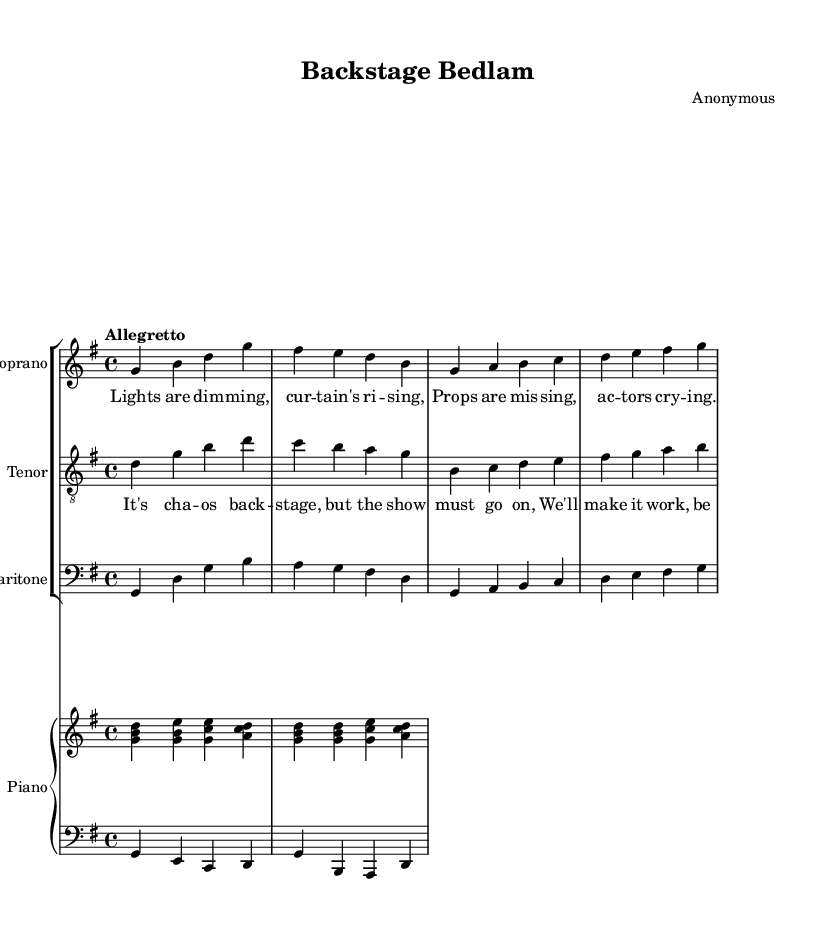What is the key signature of this music? The key signature is G major, which has one sharp (F#). We can identify this by looking at the key signature indicator at the beginning of the score.
Answer: G major What is the time signature of this music? The time signature is 4/4, which is indicated at the beginning of the score. This information tells us that there are four beats in a measure and the quarter note receives one beat.
Answer: 4/4 What is the tempo marking of the piece? The tempo marking shows "Allegretto," which indicates a moderately fast tempo. It is typically faster than Andante but slower than Allegro. This marking directs the performers on how quickly to play the piece.
Answer: Allegretto How many vocal parts are present in the score? The score includes three vocal parts: soprano, tenor, and baritone. We can determine this by examining the headers of each staff, which are clearly labeled with their respective voice types.
Answer: Three What do the lyrics describe in the first verse? The first verse describes the chaos of community theater behind the scenes, mentioning dim lights, rising curtains, missing props, and actors crying. This context reflects the comedic and chaotic theme of the opera as per the lyrics provided.
Answer: Chaos behind the scenes Which instrument is playing the bass clef in the piano staff? The bass clef in the piano staff is played by the left hand (LH) of the piano. In the layout, the second staff is distinctly indicated as having a bass clef, which represents the lower pitches that the left hand typically plays in piano music.
Answer: Left hand 